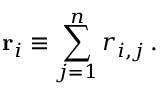Convert formula to latex. <formula><loc_0><loc_0><loc_500><loc_500>r _ { i } \equiv \sum _ { j = 1 } ^ { n } r _ { i , j } \, .</formula> 